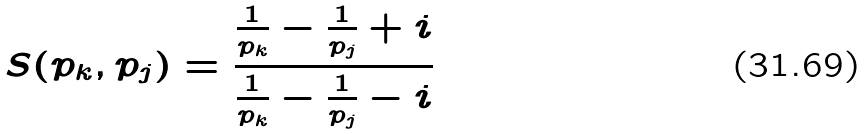Convert formula to latex. <formula><loc_0><loc_0><loc_500><loc_500>S ( p _ { k } , p _ { j } ) = \frac { \frac { 1 } { p _ { k } } - \frac { 1 } { p _ { j } } + i } { \frac { 1 } { p _ { k } } - \frac { 1 } { p _ { j } } - i }</formula> 